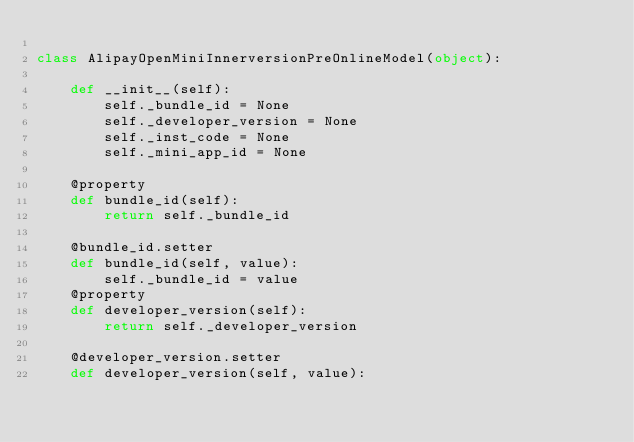<code> <loc_0><loc_0><loc_500><loc_500><_Python_>
class AlipayOpenMiniInnerversionPreOnlineModel(object):

    def __init__(self):
        self._bundle_id = None
        self._developer_version = None
        self._inst_code = None
        self._mini_app_id = None

    @property
    def bundle_id(self):
        return self._bundle_id

    @bundle_id.setter
    def bundle_id(self, value):
        self._bundle_id = value
    @property
    def developer_version(self):
        return self._developer_version

    @developer_version.setter
    def developer_version(self, value):</code> 